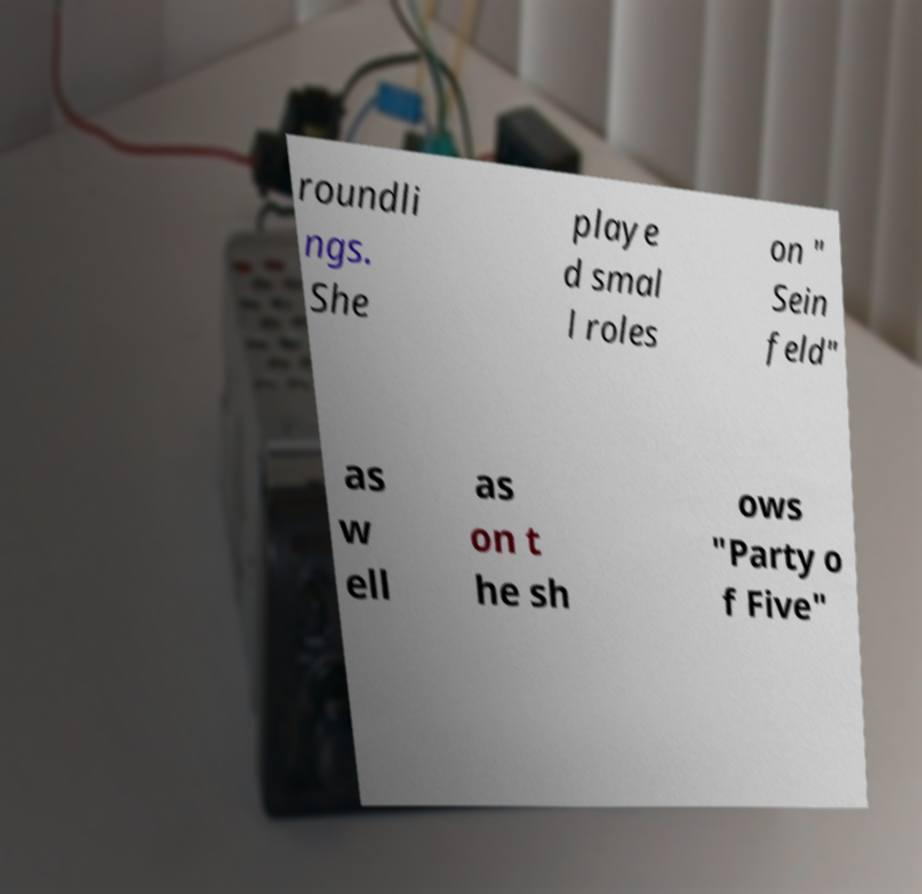Can you accurately transcribe the text from the provided image for me? roundli ngs. She playe d smal l roles on " Sein feld" as w ell as on t he sh ows "Party o f Five" 